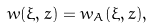Convert formula to latex. <formula><loc_0><loc_0><loc_500><loc_500>& w ( \xi , z ) = w _ { A } ( \xi , z ) ,</formula> 